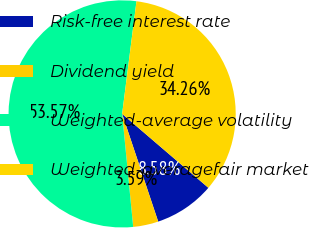<chart> <loc_0><loc_0><loc_500><loc_500><pie_chart><fcel>Risk-free interest rate<fcel>Dividend yield<fcel>Weighted-average volatility<fcel>Weighted-averagefair market<nl><fcel>8.58%<fcel>3.59%<fcel>53.56%<fcel>34.26%<nl></chart> 